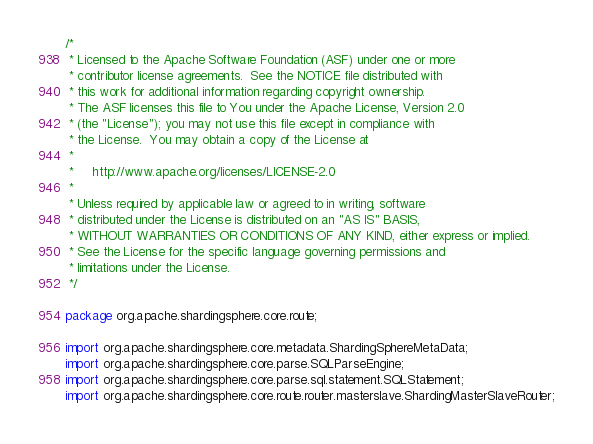<code> <loc_0><loc_0><loc_500><loc_500><_Java_>/*
 * Licensed to the Apache Software Foundation (ASF) under one or more
 * contributor license agreements.  See the NOTICE file distributed with
 * this work for additional information regarding copyright ownership.
 * The ASF licenses this file to You under the Apache License, Version 2.0
 * (the "License"); you may not use this file except in compliance with
 * the License.  You may obtain a copy of the License at
 *
 *     http://www.apache.org/licenses/LICENSE-2.0
 *
 * Unless required by applicable law or agreed to in writing, software
 * distributed under the License is distributed on an "AS IS" BASIS,
 * WITHOUT WARRANTIES OR CONDITIONS OF ANY KIND, either express or implied.
 * See the License for the specific language governing permissions and
 * limitations under the License.
 */

package org.apache.shardingsphere.core.route;

import org.apache.shardingsphere.core.metadata.ShardingSphereMetaData;
import org.apache.shardingsphere.core.parse.SQLParseEngine;
import org.apache.shardingsphere.core.parse.sql.statement.SQLStatement;
import org.apache.shardingsphere.core.route.router.masterslave.ShardingMasterSlaveRouter;</code> 